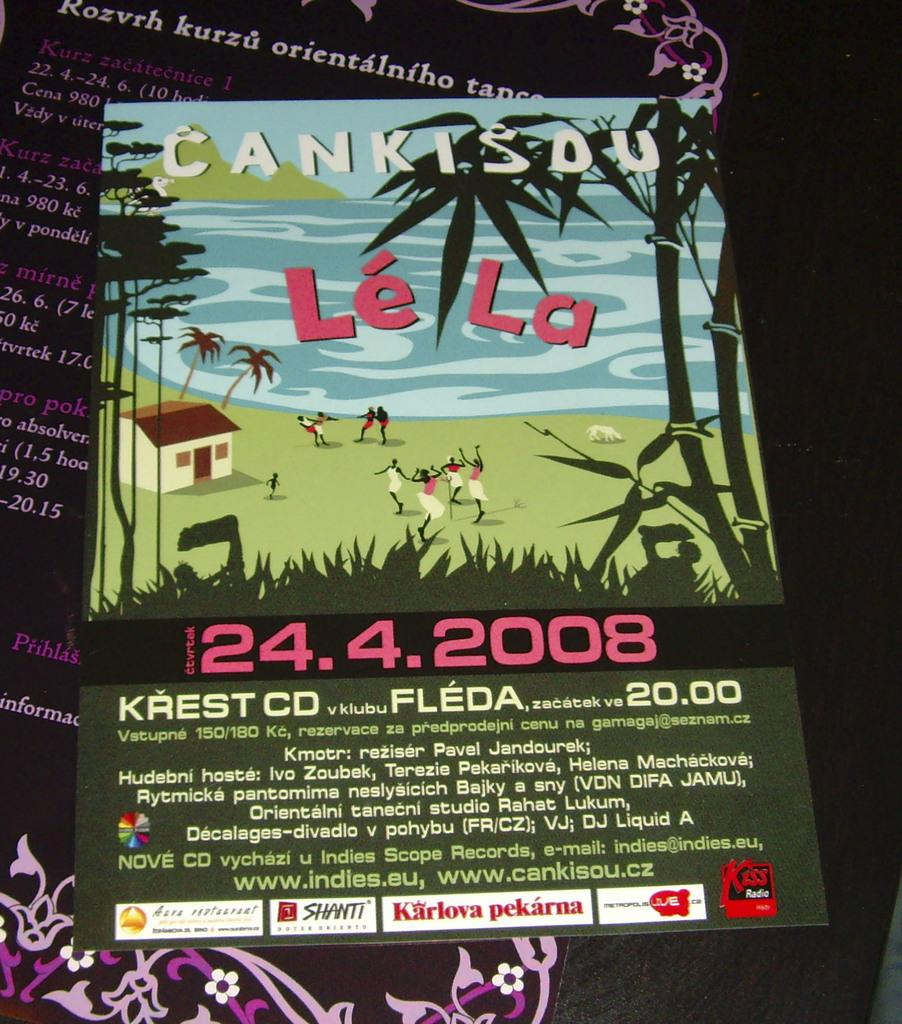<image>
Relay a brief, clear account of the picture shown. Cankisdu Le La Music Festival on April 24th, 2008. 